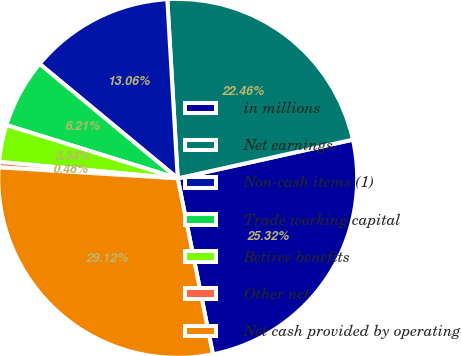Convert chart. <chart><loc_0><loc_0><loc_500><loc_500><pie_chart><fcel>in millions<fcel>Net earnings<fcel>Non-cash items (1)<fcel>Trade working capital<fcel>Retiree benefits<fcel>Other net<fcel>Net cash provided by operating<nl><fcel>25.32%<fcel>22.46%<fcel>13.06%<fcel>6.21%<fcel>3.34%<fcel>0.48%<fcel>29.12%<nl></chart> 